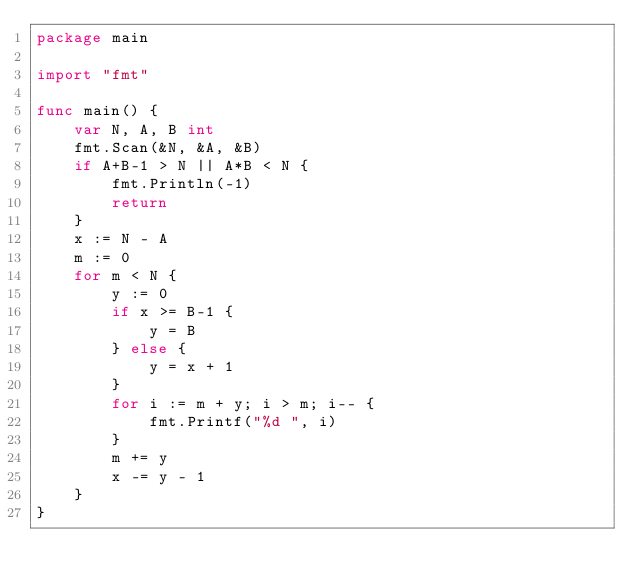<code> <loc_0><loc_0><loc_500><loc_500><_Go_>package main

import "fmt"

func main() {
	var N, A, B int
	fmt.Scan(&N, &A, &B)
	if A+B-1 > N || A*B < N {
		fmt.Println(-1)
		return
	}
	x := N - A
	m := 0
	for m < N {
		y := 0
		if x >= B-1 {
			y = B
		} else {
			y = x + 1
		}
		for i := m + y; i > m; i-- {
			fmt.Printf("%d ", i)
		}
		m += y
		x -= y - 1
	}
}
</code> 